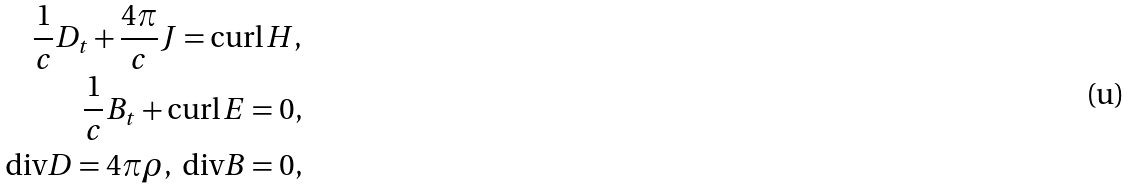<formula> <loc_0><loc_0><loc_500><loc_500>\frac { 1 } { c } D _ { t } + \frac { 4 \pi } { c } J = \text {curl} \, H , \\ \frac { 1 } { c } B _ { t } + \text {curl} \, E = 0 , \\ \text {div} D = 4 \pi \rho , \ \text {div} B = 0 ,</formula> 